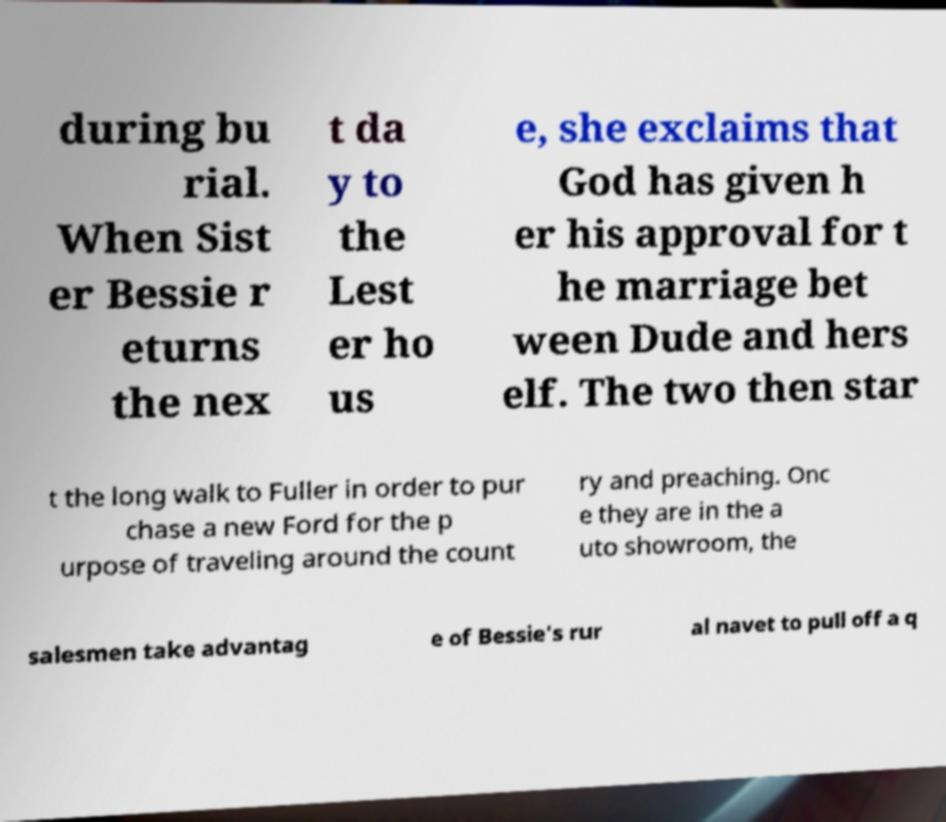Please identify and transcribe the text found in this image. during bu rial. When Sist er Bessie r eturns the nex t da y to the Lest er ho us e, she exclaims that God has given h er his approval for t he marriage bet ween Dude and hers elf. The two then star t the long walk to Fuller in order to pur chase a new Ford for the p urpose of traveling around the count ry and preaching. Onc e they are in the a uto showroom, the salesmen take advantag e of Bessie's rur al navet to pull off a q 